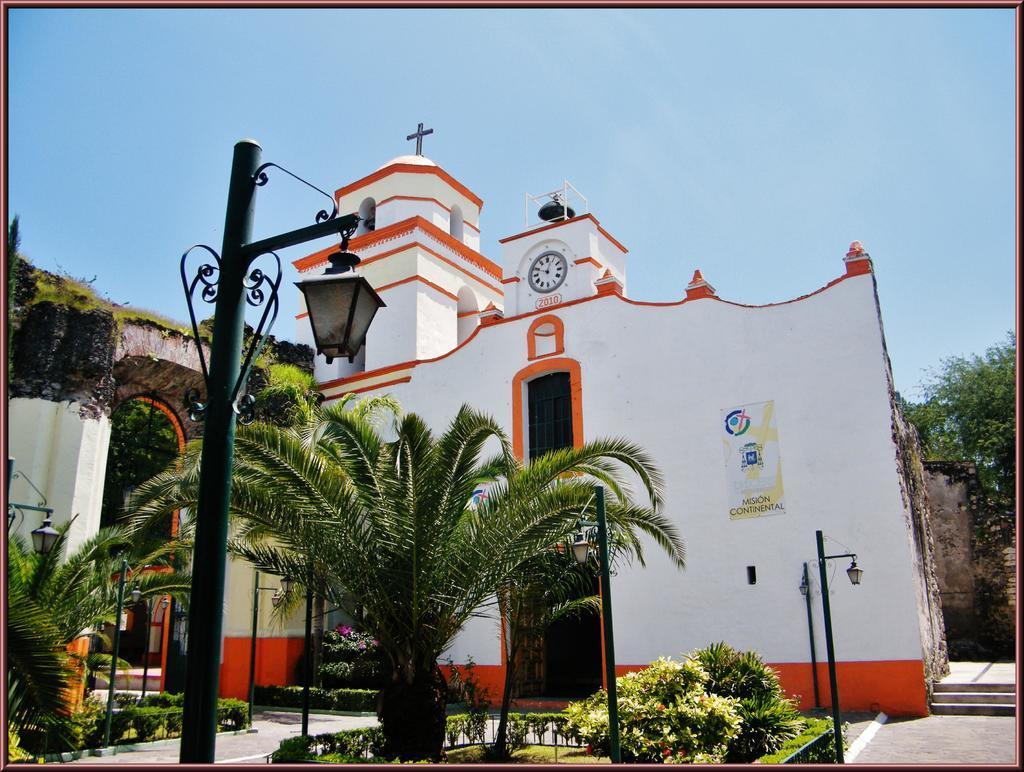In one or two sentences, can you explain what this image depicts? In this image I can see buildings,trees,poles,light poles,window and a clock. The sky is in white and blue color. 